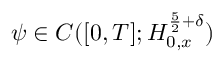<formula> <loc_0><loc_0><loc_500><loc_500>\psi \in C ( [ 0 , T ] ; H _ { 0 , x } ^ { \frac { 5 } { 2 } + \delta } )</formula> 